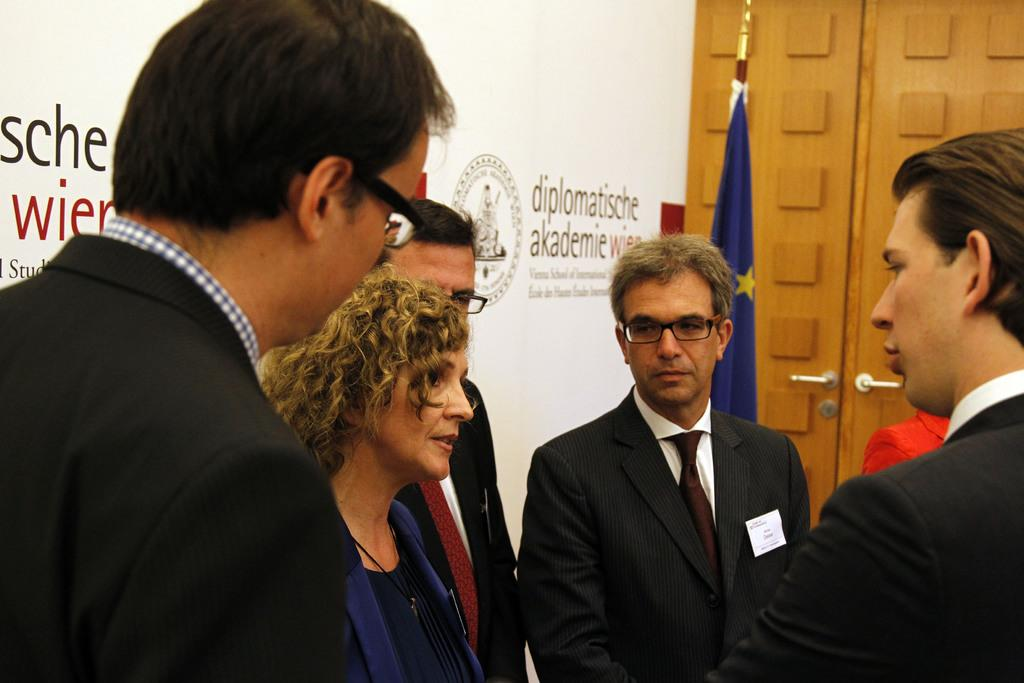How many people are in the image? There are multiple people in the image. What are the people in the image doing? The people are standing in a group. What can be seen attached to a pole in the image? There is a flag attached to a pole in the image. What is present at the back of the group in the image? There is a banner present at the back. What type of bait is being used in the competition in the image? There is no competition or bait present in the image; it features a group of people standing together with a flag and banner. 